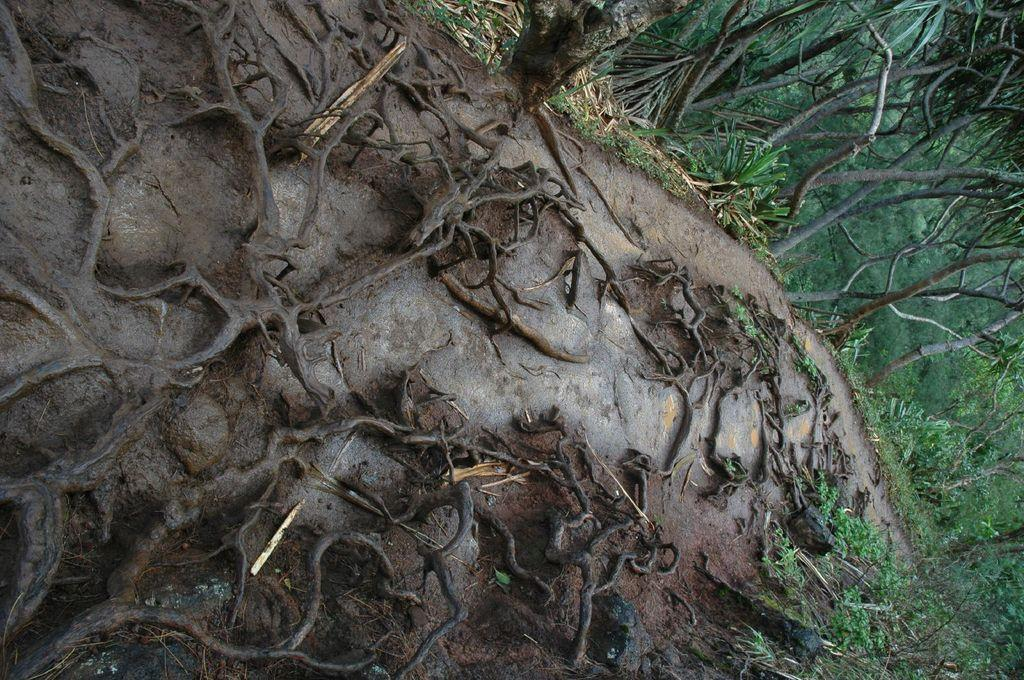What type of plant structures can be seen in the image? There are roots of plants in the image. What can be seen in the distance in the image? There are trees visible in the background of the image. What flavor of ice cream is being enjoyed by the ghost in the image? There is no ghost or ice cream present in the image; it features plant roots and trees in the background. 